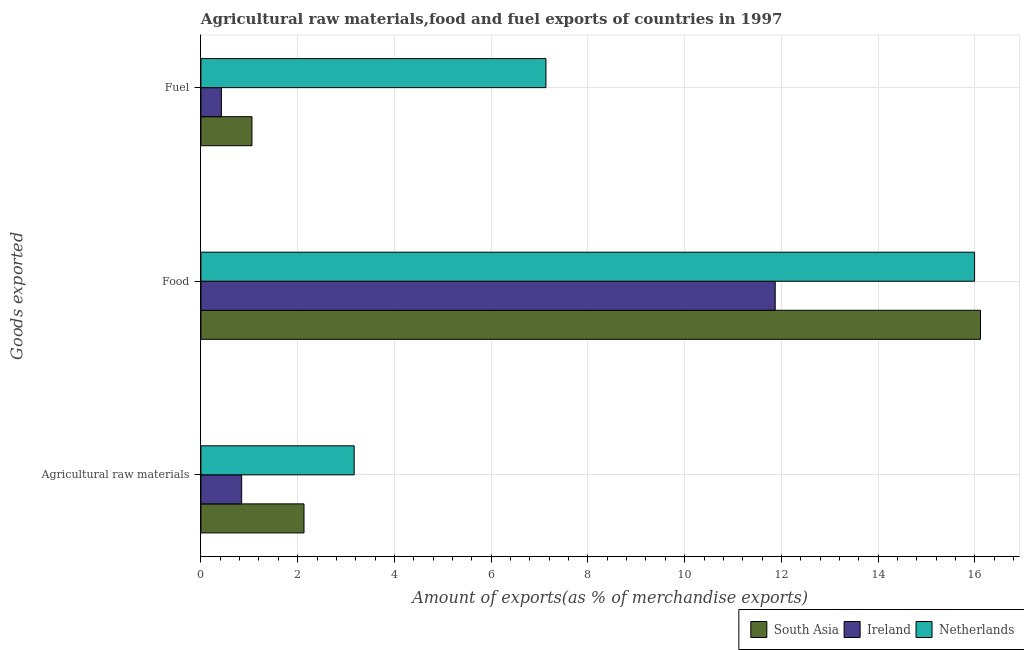Are the number of bars per tick equal to the number of legend labels?
Your answer should be very brief. Yes. Are the number of bars on each tick of the Y-axis equal?
Offer a terse response. Yes. How many bars are there on the 1st tick from the top?
Offer a very short reply. 3. What is the label of the 1st group of bars from the top?
Your response must be concise. Fuel. What is the percentage of fuel exports in South Asia?
Your answer should be compact. 1.05. Across all countries, what is the maximum percentage of food exports?
Keep it short and to the point. 16.11. Across all countries, what is the minimum percentage of food exports?
Your response must be concise. 11.87. In which country was the percentage of raw materials exports maximum?
Give a very brief answer. Netherlands. In which country was the percentage of food exports minimum?
Give a very brief answer. Ireland. What is the total percentage of raw materials exports in the graph?
Your answer should be very brief. 6.14. What is the difference between the percentage of raw materials exports in South Asia and that in Netherlands?
Provide a succinct answer. -1.04. What is the difference between the percentage of fuel exports in Netherlands and the percentage of raw materials exports in Ireland?
Your answer should be very brief. 6.29. What is the average percentage of raw materials exports per country?
Provide a succinct answer. 2.05. What is the difference between the percentage of raw materials exports and percentage of food exports in Netherlands?
Offer a very short reply. -12.82. In how many countries, is the percentage of raw materials exports greater than 11.6 %?
Your response must be concise. 0. What is the ratio of the percentage of food exports in Ireland to that in South Asia?
Give a very brief answer. 0.74. Is the difference between the percentage of fuel exports in Netherlands and Ireland greater than the difference between the percentage of food exports in Netherlands and Ireland?
Offer a very short reply. Yes. What is the difference between the highest and the second highest percentage of raw materials exports?
Offer a terse response. 1.04. What is the difference between the highest and the lowest percentage of raw materials exports?
Provide a short and direct response. 2.33. In how many countries, is the percentage of fuel exports greater than the average percentage of fuel exports taken over all countries?
Give a very brief answer. 1. Is the sum of the percentage of fuel exports in Netherlands and Ireland greater than the maximum percentage of food exports across all countries?
Offer a terse response. No. What does the 2nd bar from the top in Food represents?
Keep it short and to the point. Ireland. Is it the case that in every country, the sum of the percentage of raw materials exports and percentage of food exports is greater than the percentage of fuel exports?
Provide a short and direct response. Yes. Are all the bars in the graph horizontal?
Provide a succinct answer. Yes. Are the values on the major ticks of X-axis written in scientific E-notation?
Offer a very short reply. No. Does the graph contain any zero values?
Offer a terse response. No. Does the graph contain grids?
Offer a terse response. Yes. Where does the legend appear in the graph?
Make the answer very short. Bottom right. How many legend labels are there?
Make the answer very short. 3. How are the legend labels stacked?
Make the answer very short. Horizontal. What is the title of the graph?
Your answer should be compact. Agricultural raw materials,food and fuel exports of countries in 1997. Does "Virgin Islands" appear as one of the legend labels in the graph?
Ensure brevity in your answer.  No. What is the label or title of the X-axis?
Your response must be concise. Amount of exports(as % of merchandise exports). What is the label or title of the Y-axis?
Provide a succinct answer. Goods exported. What is the Amount of exports(as % of merchandise exports) in South Asia in Agricultural raw materials?
Ensure brevity in your answer.  2.13. What is the Amount of exports(as % of merchandise exports) of Ireland in Agricultural raw materials?
Offer a very short reply. 0.84. What is the Amount of exports(as % of merchandise exports) in Netherlands in Agricultural raw materials?
Offer a very short reply. 3.17. What is the Amount of exports(as % of merchandise exports) in South Asia in Food?
Keep it short and to the point. 16.11. What is the Amount of exports(as % of merchandise exports) of Ireland in Food?
Your response must be concise. 11.87. What is the Amount of exports(as % of merchandise exports) in Netherlands in Food?
Your response must be concise. 15.99. What is the Amount of exports(as % of merchandise exports) in South Asia in Fuel?
Ensure brevity in your answer.  1.05. What is the Amount of exports(as % of merchandise exports) of Ireland in Fuel?
Your answer should be very brief. 0.42. What is the Amount of exports(as % of merchandise exports) in Netherlands in Fuel?
Provide a succinct answer. 7.13. Across all Goods exported, what is the maximum Amount of exports(as % of merchandise exports) of South Asia?
Your answer should be very brief. 16.11. Across all Goods exported, what is the maximum Amount of exports(as % of merchandise exports) of Ireland?
Your answer should be very brief. 11.87. Across all Goods exported, what is the maximum Amount of exports(as % of merchandise exports) in Netherlands?
Give a very brief answer. 15.99. Across all Goods exported, what is the minimum Amount of exports(as % of merchandise exports) in South Asia?
Provide a succinct answer. 1.05. Across all Goods exported, what is the minimum Amount of exports(as % of merchandise exports) of Ireland?
Keep it short and to the point. 0.42. Across all Goods exported, what is the minimum Amount of exports(as % of merchandise exports) of Netherlands?
Give a very brief answer. 3.17. What is the total Amount of exports(as % of merchandise exports) of South Asia in the graph?
Keep it short and to the point. 19.3. What is the total Amount of exports(as % of merchandise exports) in Ireland in the graph?
Offer a very short reply. 13.14. What is the total Amount of exports(as % of merchandise exports) of Netherlands in the graph?
Your answer should be very brief. 26.29. What is the difference between the Amount of exports(as % of merchandise exports) in South Asia in Agricultural raw materials and that in Food?
Provide a short and direct response. -13.98. What is the difference between the Amount of exports(as % of merchandise exports) of Ireland in Agricultural raw materials and that in Food?
Keep it short and to the point. -11.03. What is the difference between the Amount of exports(as % of merchandise exports) in Netherlands in Agricultural raw materials and that in Food?
Keep it short and to the point. -12.82. What is the difference between the Amount of exports(as % of merchandise exports) of South Asia in Agricultural raw materials and that in Fuel?
Give a very brief answer. 1.08. What is the difference between the Amount of exports(as % of merchandise exports) of Ireland in Agricultural raw materials and that in Fuel?
Your answer should be very brief. 0.42. What is the difference between the Amount of exports(as % of merchandise exports) of Netherlands in Agricultural raw materials and that in Fuel?
Provide a short and direct response. -3.96. What is the difference between the Amount of exports(as % of merchandise exports) in South Asia in Food and that in Fuel?
Keep it short and to the point. 15.06. What is the difference between the Amount of exports(as % of merchandise exports) in Ireland in Food and that in Fuel?
Ensure brevity in your answer.  11.45. What is the difference between the Amount of exports(as % of merchandise exports) in Netherlands in Food and that in Fuel?
Provide a succinct answer. 8.86. What is the difference between the Amount of exports(as % of merchandise exports) of South Asia in Agricultural raw materials and the Amount of exports(as % of merchandise exports) of Ireland in Food?
Give a very brief answer. -9.74. What is the difference between the Amount of exports(as % of merchandise exports) of South Asia in Agricultural raw materials and the Amount of exports(as % of merchandise exports) of Netherlands in Food?
Your response must be concise. -13.86. What is the difference between the Amount of exports(as % of merchandise exports) of Ireland in Agricultural raw materials and the Amount of exports(as % of merchandise exports) of Netherlands in Food?
Your answer should be compact. -15.15. What is the difference between the Amount of exports(as % of merchandise exports) in South Asia in Agricultural raw materials and the Amount of exports(as % of merchandise exports) in Ireland in Fuel?
Give a very brief answer. 1.71. What is the difference between the Amount of exports(as % of merchandise exports) of South Asia in Agricultural raw materials and the Amount of exports(as % of merchandise exports) of Netherlands in Fuel?
Offer a terse response. -5. What is the difference between the Amount of exports(as % of merchandise exports) in Ireland in Agricultural raw materials and the Amount of exports(as % of merchandise exports) in Netherlands in Fuel?
Offer a very short reply. -6.29. What is the difference between the Amount of exports(as % of merchandise exports) in South Asia in Food and the Amount of exports(as % of merchandise exports) in Ireland in Fuel?
Your answer should be compact. 15.69. What is the difference between the Amount of exports(as % of merchandise exports) of South Asia in Food and the Amount of exports(as % of merchandise exports) of Netherlands in Fuel?
Make the answer very short. 8.98. What is the difference between the Amount of exports(as % of merchandise exports) of Ireland in Food and the Amount of exports(as % of merchandise exports) of Netherlands in Fuel?
Keep it short and to the point. 4.74. What is the average Amount of exports(as % of merchandise exports) of South Asia per Goods exported?
Offer a very short reply. 6.43. What is the average Amount of exports(as % of merchandise exports) in Ireland per Goods exported?
Offer a very short reply. 4.38. What is the average Amount of exports(as % of merchandise exports) of Netherlands per Goods exported?
Give a very brief answer. 8.76. What is the difference between the Amount of exports(as % of merchandise exports) in South Asia and Amount of exports(as % of merchandise exports) in Ireland in Agricultural raw materials?
Your answer should be compact. 1.29. What is the difference between the Amount of exports(as % of merchandise exports) of South Asia and Amount of exports(as % of merchandise exports) of Netherlands in Agricultural raw materials?
Ensure brevity in your answer.  -1.04. What is the difference between the Amount of exports(as % of merchandise exports) in Ireland and Amount of exports(as % of merchandise exports) in Netherlands in Agricultural raw materials?
Your response must be concise. -2.33. What is the difference between the Amount of exports(as % of merchandise exports) in South Asia and Amount of exports(as % of merchandise exports) in Ireland in Food?
Offer a terse response. 4.24. What is the difference between the Amount of exports(as % of merchandise exports) of South Asia and Amount of exports(as % of merchandise exports) of Netherlands in Food?
Provide a succinct answer. 0.12. What is the difference between the Amount of exports(as % of merchandise exports) in Ireland and Amount of exports(as % of merchandise exports) in Netherlands in Food?
Your answer should be very brief. -4.12. What is the difference between the Amount of exports(as % of merchandise exports) of South Asia and Amount of exports(as % of merchandise exports) of Ireland in Fuel?
Provide a short and direct response. 0.63. What is the difference between the Amount of exports(as % of merchandise exports) of South Asia and Amount of exports(as % of merchandise exports) of Netherlands in Fuel?
Offer a very short reply. -6.08. What is the difference between the Amount of exports(as % of merchandise exports) of Ireland and Amount of exports(as % of merchandise exports) of Netherlands in Fuel?
Ensure brevity in your answer.  -6.71. What is the ratio of the Amount of exports(as % of merchandise exports) in South Asia in Agricultural raw materials to that in Food?
Your answer should be compact. 0.13. What is the ratio of the Amount of exports(as % of merchandise exports) of Ireland in Agricultural raw materials to that in Food?
Offer a terse response. 0.07. What is the ratio of the Amount of exports(as % of merchandise exports) of Netherlands in Agricultural raw materials to that in Food?
Make the answer very short. 0.2. What is the ratio of the Amount of exports(as % of merchandise exports) in South Asia in Agricultural raw materials to that in Fuel?
Your answer should be compact. 2.02. What is the ratio of the Amount of exports(as % of merchandise exports) in Ireland in Agricultural raw materials to that in Fuel?
Make the answer very short. 1.99. What is the ratio of the Amount of exports(as % of merchandise exports) of Netherlands in Agricultural raw materials to that in Fuel?
Your answer should be compact. 0.44. What is the ratio of the Amount of exports(as % of merchandise exports) in South Asia in Food to that in Fuel?
Your response must be concise. 15.28. What is the ratio of the Amount of exports(as % of merchandise exports) of Ireland in Food to that in Fuel?
Give a very brief answer. 28.04. What is the ratio of the Amount of exports(as % of merchandise exports) in Netherlands in Food to that in Fuel?
Your response must be concise. 2.24. What is the difference between the highest and the second highest Amount of exports(as % of merchandise exports) of South Asia?
Ensure brevity in your answer.  13.98. What is the difference between the highest and the second highest Amount of exports(as % of merchandise exports) in Ireland?
Your answer should be compact. 11.03. What is the difference between the highest and the second highest Amount of exports(as % of merchandise exports) of Netherlands?
Keep it short and to the point. 8.86. What is the difference between the highest and the lowest Amount of exports(as % of merchandise exports) in South Asia?
Provide a succinct answer. 15.06. What is the difference between the highest and the lowest Amount of exports(as % of merchandise exports) in Ireland?
Give a very brief answer. 11.45. What is the difference between the highest and the lowest Amount of exports(as % of merchandise exports) in Netherlands?
Provide a succinct answer. 12.82. 